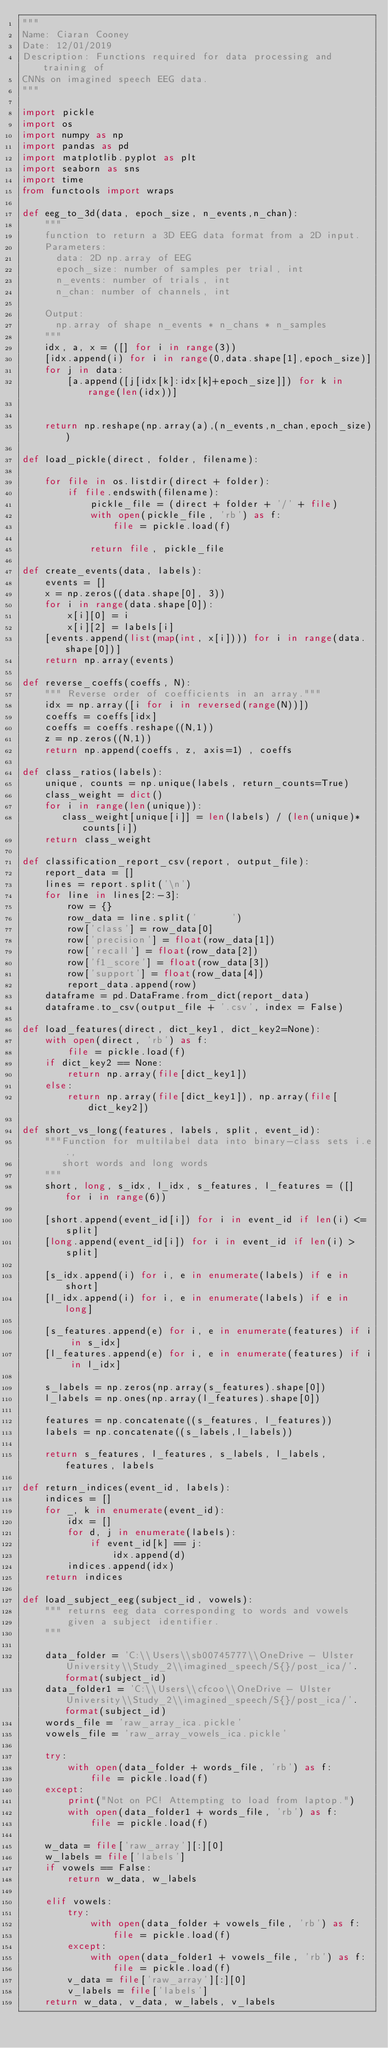<code> <loc_0><loc_0><loc_500><loc_500><_Python_>"""
Name: Ciaran Cooney
Date: 12/01/2019
Description: Functions required for data processing and training of 
CNNs on imagined speech EEG data.
"""

import pickle
import os
import numpy as np 
import pandas as pd
import matplotlib.pyplot as plt
import seaborn as sns
import time
from functools import wraps

def eeg_to_3d(data, epoch_size, n_events,n_chan):
    """
    function to return a 3D EEG data format from a 2D input.
    Parameters:
      data: 2D np.array of EEG
      epoch_size: number of samples per trial, int
      n_events: number of trials, int
      n_chan: number of channels, int
        
    Output:
      np.array of shape n_events * n_chans * n_samples
    """
    idx, a, x = ([] for i in range(3))
    [idx.append(i) for i in range(0,data.shape[1],epoch_size)]
    for j in data:
        [a.append([j[idx[k]:idx[k]+epoch_size]]) for k in range(len(idx))]
   
    
    return np.reshape(np.array(a),(n_events,n_chan,epoch_size))

def load_pickle(direct, folder, filename):
    
    for file in os.listdir(direct + folder):
        if file.endswith(filename):
            pickle_file = (direct + folder + '/' + file)
            with open(pickle_file, 'rb') as f:
                file = pickle.load(f)

            return file, pickle_file

def create_events(data, labels):
    events = []
    x = np.zeros((data.shape[0], 3))
    for i in range(data.shape[0]):
        x[i][0] = i 
        x[i][2] = labels[i]
    [events.append(list(map(int, x[i]))) for i in range(data.shape[0])]
    return np.array(events)

def reverse_coeffs(coeffs, N):
    """ Reverse order of coefficients in an array."""
    idx = np.array([i for i in reversed(range(N))])
    coeffs = coeffs[idx]
    coeffs = coeffs.reshape((N,1))
    z = np.zeros((N,1))
    return np.append(coeffs, z, axis=1) , coeffs

def class_ratios(labels):
    unique, counts = np.unique(labels, return_counts=True)
    class_weight = dict()
    for i in range(len(unique)):
       class_weight[unique[i]] = len(labels) / (len(unique)*counts[i])
    return class_weight

def classification_report_csv(report, output_file):
    report_data = []
    lines = report.split('\n')
    for line in lines[2:-3]:
        row = {}
        row_data = line.split('      ')
        row['class'] = row_data[0]
        row['precision'] = float(row_data[1])
        row['recall'] = float(row_data[2])
        row['f1_score'] = float(row_data[3])
        row['support'] = float(row_data[4])
        report_data.append(row)
    dataframe = pd.DataFrame.from_dict(report_data)
    dataframe.to_csv(output_file + '.csv', index = False)

def load_features(direct, dict_key1, dict_key2=None):
    with open(direct, 'rb') as f:
        file = pickle.load(f)
    if dict_key2 == None:
        return np.array(file[dict_key1])
    else:
        return np.array(file[dict_key1]), np.array(file[dict_key2])

def short_vs_long(features, labels, split, event_id):
    """Function for multilabel data into binary-class sets i.e.,
       short words and long words
    """
    short, long, s_idx, l_idx, s_features, l_features = ([] for i in range(6))
    
    [short.append(event_id[i]) for i in event_id if len(i) <= split]
    [long.append(event_id[i]) for i in event_id if len(i) > split]
    
    [s_idx.append(i) for i, e in enumerate(labels) if e in short]
    [l_idx.append(i) for i, e in enumerate(labels) if e in long]
    
    [s_features.append(e) for i, e in enumerate(features) if i in s_idx]
    [l_features.append(e) for i, e in enumerate(features) if i in l_idx]
    
    s_labels = np.zeros(np.array(s_features).shape[0])
    l_labels = np.ones(np.array(l_features).shape[0])

    features = np.concatenate((s_features, l_features))
    labels = np.concatenate((s_labels,l_labels))
    
    return s_features, l_features, s_labels, l_labels, features, labels 

def return_indices(event_id, labels):
    indices = []
    for _, k in enumerate(event_id):
        idx = []
        for d, j in enumerate(labels):
            if event_id[k] == j:
                idx.append(d)
        indices.append(idx)
    return indices

def load_subject_eeg(subject_id, vowels):
    """ returns eeg data corresponding to words and vowels 
        given a subject identifier.
    """

    data_folder = 'C:\\Users\\sb00745777\\OneDrive - Ulster University\\Study_2\\imagined_speech/S{}/post_ica/'.format(subject_id)
    data_folder1 = 'C:\\Users\\cfcoo\\OneDrive - Ulster University\\Study_2\\imagined_speech/S{}/post_ica/'.format(subject_id)
    words_file = 'raw_array_ica.pickle'
    vowels_file = 'raw_array_vowels_ica.pickle'
    
    try:
        with open(data_folder + words_file, 'rb') as f:
            file = pickle.load(f)
    except:
        print("Not on PC! Attempting to load from laptop.")
        with open(data_folder1 + words_file, 'rb') as f:
            file = pickle.load(f)
            
    w_data = file['raw_array'][:][0]
    w_labels = file['labels']
    if vowels == False:
        return w_data, w_labels

    elif vowels:
        try:
            with open(data_folder + vowels_file, 'rb') as f:
                file = pickle.load(f)
        except:
            with open(data_folder1 + vowels_file, 'rb') as f:
                file = pickle.load(f)
        v_data = file['raw_array'][:][0]
        v_labels = file['labels']
    return w_data, v_data, w_labels, v_labels
</code> 